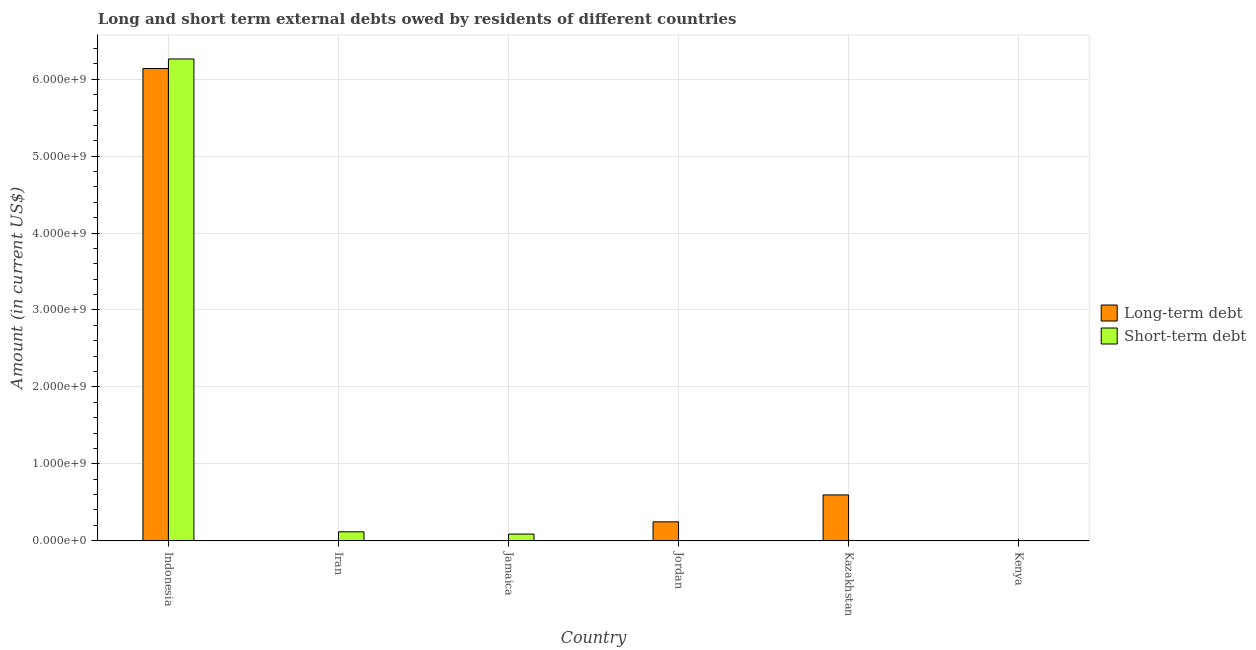Are the number of bars per tick equal to the number of legend labels?
Ensure brevity in your answer.  No. How many bars are there on the 1st tick from the left?
Provide a short and direct response. 2. What is the label of the 1st group of bars from the left?
Ensure brevity in your answer.  Indonesia. In how many cases, is the number of bars for a given country not equal to the number of legend labels?
Provide a succinct answer. 4. What is the short-term debts owed by residents in Iran?
Provide a short and direct response. 1.16e+08. Across all countries, what is the maximum short-term debts owed by residents?
Keep it short and to the point. 6.26e+09. Across all countries, what is the minimum short-term debts owed by residents?
Your response must be concise. 0. In which country was the long-term debts owed by residents maximum?
Your answer should be very brief. Indonesia. What is the total short-term debts owed by residents in the graph?
Your answer should be compact. 6.47e+09. What is the difference between the short-term debts owed by residents in Indonesia and that in Iran?
Your answer should be compact. 6.15e+09. What is the difference between the short-term debts owed by residents in Iran and the long-term debts owed by residents in Jordan?
Your answer should be compact. -1.29e+08. What is the average short-term debts owed by residents per country?
Provide a short and direct response. 1.08e+09. What is the difference between the short-term debts owed by residents and long-term debts owed by residents in Kazakhstan?
Give a very brief answer. -5.94e+08. What is the ratio of the long-term debts owed by residents in Jordan to that in Kazakhstan?
Ensure brevity in your answer.  0.41. Is the short-term debts owed by residents in Indonesia less than that in Iran?
Give a very brief answer. No. What is the difference between the highest and the second highest short-term debts owed by residents?
Make the answer very short. 6.15e+09. What is the difference between the highest and the lowest short-term debts owed by residents?
Ensure brevity in your answer.  6.26e+09. In how many countries, is the short-term debts owed by residents greater than the average short-term debts owed by residents taken over all countries?
Provide a succinct answer. 1. How many bars are there?
Offer a terse response. 7. Are all the bars in the graph horizontal?
Keep it short and to the point. No. How many countries are there in the graph?
Your answer should be very brief. 6. What is the title of the graph?
Provide a succinct answer. Long and short term external debts owed by residents of different countries. What is the label or title of the X-axis?
Offer a terse response. Country. What is the label or title of the Y-axis?
Provide a succinct answer. Amount (in current US$). What is the Amount (in current US$) of Long-term debt in Indonesia?
Ensure brevity in your answer.  6.14e+09. What is the Amount (in current US$) in Short-term debt in Indonesia?
Your answer should be compact. 6.26e+09. What is the Amount (in current US$) in Short-term debt in Iran?
Your answer should be very brief. 1.16e+08. What is the Amount (in current US$) in Long-term debt in Jamaica?
Your response must be concise. 0. What is the Amount (in current US$) in Short-term debt in Jamaica?
Your answer should be compact. 8.66e+07. What is the Amount (in current US$) in Long-term debt in Jordan?
Ensure brevity in your answer.  2.45e+08. What is the Amount (in current US$) of Short-term debt in Jordan?
Your answer should be very brief. 0. What is the Amount (in current US$) in Long-term debt in Kazakhstan?
Provide a short and direct response. 5.96e+08. What is the Amount (in current US$) in Short-term debt in Kazakhstan?
Give a very brief answer. 1.55e+06. What is the Amount (in current US$) of Long-term debt in Kenya?
Your response must be concise. 0. What is the Amount (in current US$) of Short-term debt in Kenya?
Give a very brief answer. 0. Across all countries, what is the maximum Amount (in current US$) in Long-term debt?
Your answer should be very brief. 6.14e+09. Across all countries, what is the maximum Amount (in current US$) in Short-term debt?
Ensure brevity in your answer.  6.26e+09. Across all countries, what is the minimum Amount (in current US$) in Short-term debt?
Offer a very short reply. 0. What is the total Amount (in current US$) of Long-term debt in the graph?
Your response must be concise. 6.98e+09. What is the total Amount (in current US$) in Short-term debt in the graph?
Your response must be concise. 6.47e+09. What is the difference between the Amount (in current US$) of Short-term debt in Indonesia and that in Iran?
Your response must be concise. 6.15e+09. What is the difference between the Amount (in current US$) of Short-term debt in Indonesia and that in Jamaica?
Give a very brief answer. 6.18e+09. What is the difference between the Amount (in current US$) in Long-term debt in Indonesia and that in Jordan?
Provide a short and direct response. 5.89e+09. What is the difference between the Amount (in current US$) in Long-term debt in Indonesia and that in Kazakhstan?
Ensure brevity in your answer.  5.54e+09. What is the difference between the Amount (in current US$) of Short-term debt in Indonesia and that in Kazakhstan?
Keep it short and to the point. 6.26e+09. What is the difference between the Amount (in current US$) of Short-term debt in Iran and that in Jamaica?
Provide a succinct answer. 2.94e+07. What is the difference between the Amount (in current US$) in Short-term debt in Iran and that in Kazakhstan?
Your answer should be very brief. 1.14e+08. What is the difference between the Amount (in current US$) in Short-term debt in Jamaica and that in Kazakhstan?
Your answer should be very brief. 8.50e+07. What is the difference between the Amount (in current US$) in Long-term debt in Jordan and that in Kazakhstan?
Give a very brief answer. -3.50e+08. What is the difference between the Amount (in current US$) in Long-term debt in Indonesia and the Amount (in current US$) in Short-term debt in Iran?
Offer a terse response. 6.02e+09. What is the difference between the Amount (in current US$) of Long-term debt in Indonesia and the Amount (in current US$) of Short-term debt in Jamaica?
Provide a short and direct response. 6.05e+09. What is the difference between the Amount (in current US$) of Long-term debt in Indonesia and the Amount (in current US$) of Short-term debt in Kazakhstan?
Your response must be concise. 6.14e+09. What is the difference between the Amount (in current US$) in Long-term debt in Jordan and the Amount (in current US$) in Short-term debt in Kazakhstan?
Your answer should be very brief. 2.44e+08. What is the average Amount (in current US$) of Long-term debt per country?
Your response must be concise. 1.16e+09. What is the average Amount (in current US$) in Short-term debt per country?
Your answer should be compact. 1.08e+09. What is the difference between the Amount (in current US$) of Long-term debt and Amount (in current US$) of Short-term debt in Indonesia?
Your response must be concise. -1.24e+08. What is the difference between the Amount (in current US$) in Long-term debt and Amount (in current US$) in Short-term debt in Kazakhstan?
Provide a short and direct response. 5.94e+08. What is the ratio of the Amount (in current US$) of Short-term debt in Indonesia to that in Iran?
Give a very brief answer. 54. What is the ratio of the Amount (in current US$) of Short-term debt in Indonesia to that in Jamaica?
Your answer should be compact. 72.33. What is the ratio of the Amount (in current US$) in Long-term debt in Indonesia to that in Jordan?
Offer a terse response. 25.02. What is the ratio of the Amount (in current US$) of Long-term debt in Indonesia to that in Kazakhstan?
Ensure brevity in your answer.  10.31. What is the ratio of the Amount (in current US$) in Short-term debt in Indonesia to that in Kazakhstan?
Give a very brief answer. 4041.38. What is the ratio of the Amount (in current US$) of Short-term debt in Iran to that in Jamaica?
Make the answer very short. 1.34. What is the ratio of the Amount (in current US$) in Short-term debt in Iran to that in Kazakhstan?
Make the answer very short. 74.84. What is the ratio of the Amount (in current US$) of Short-term debt in Jamaica to that in Kazakhstan?
Your answer should be compact. 55.87. What is the ratio of the Amount (in current US$) in Long-term debt in Jordan to that in Kazakhstan?
Keep it short and to the point. 0.41. What is the difference between the highest and the second highest Amount (in current US$) of Long-term debt?
Your answer should be compact. 5.54e+09. What is the difference between the highest and the second highest Amount (in current US$) in Short-term debt?
Keep it short and to the point. 6.15e+09. What is the difference between the highest and the lowest Amount (in current US$) in Long-term debt?
Provide a succinct answer. 6.14e+09. What is the difference between the highest and the lowest Amount (in current US$) in Short-term debt?
Your response must be concise. 6.26e+09. 